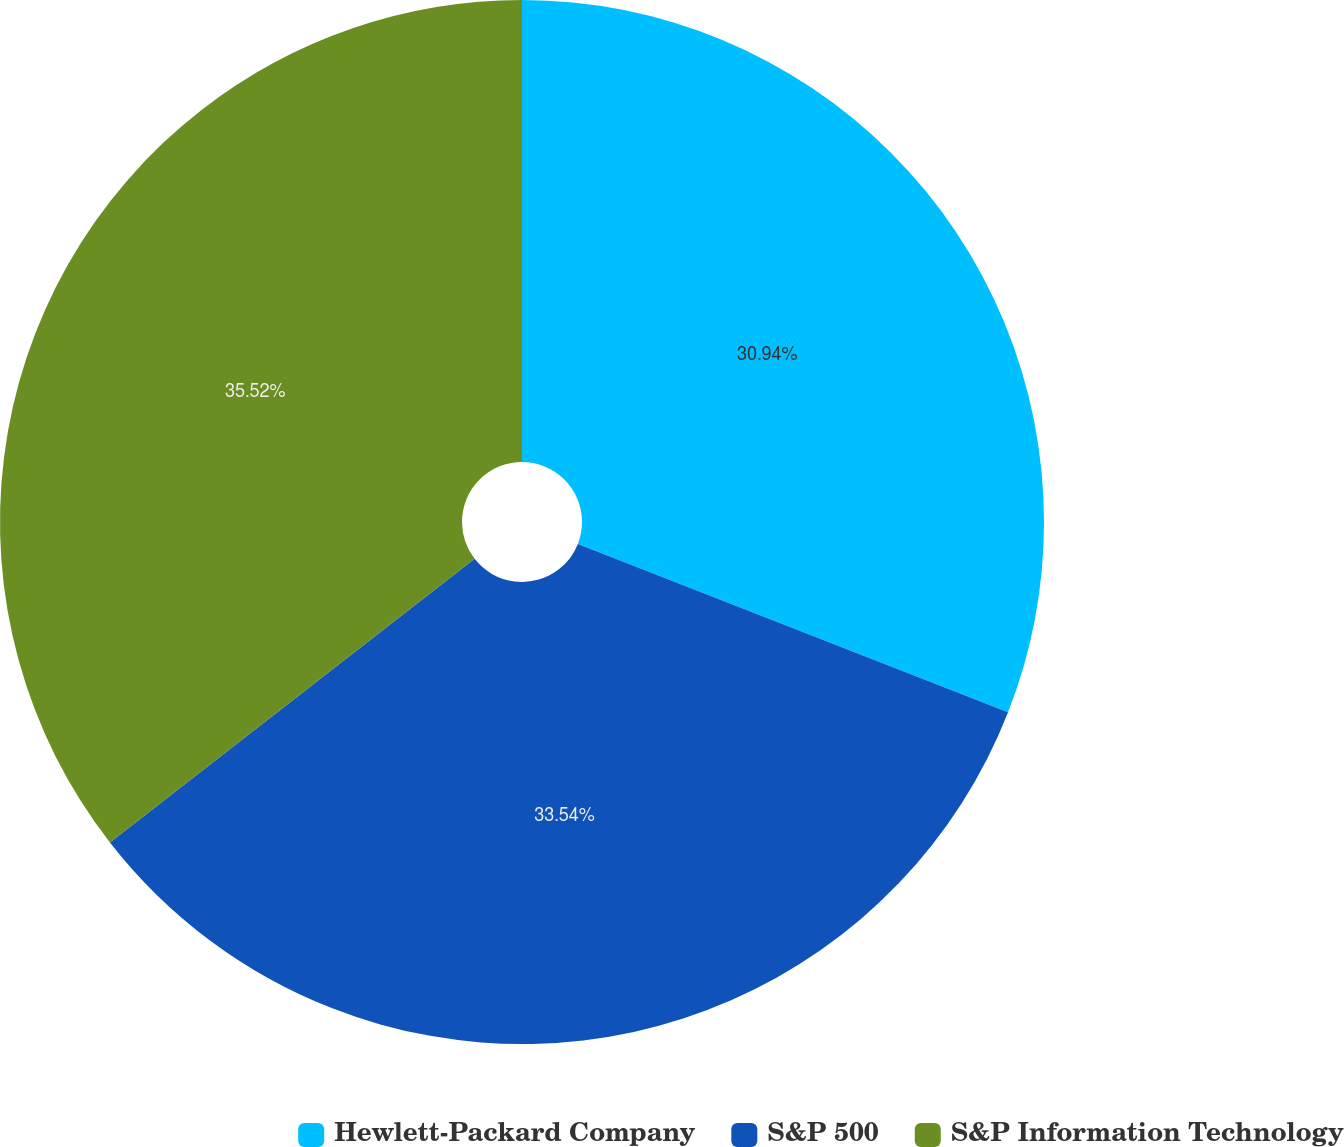Convert chart. <chart><loc_0><loc_0><loc_500><loc_500><pie_chart><fcel>Hewlett-Packard Company<fcel>S&P 500<fcel>S&P Information Technology<nl><fcel>30.94%<fcel>33.54%<fcel>35.52%<nl></chart> 